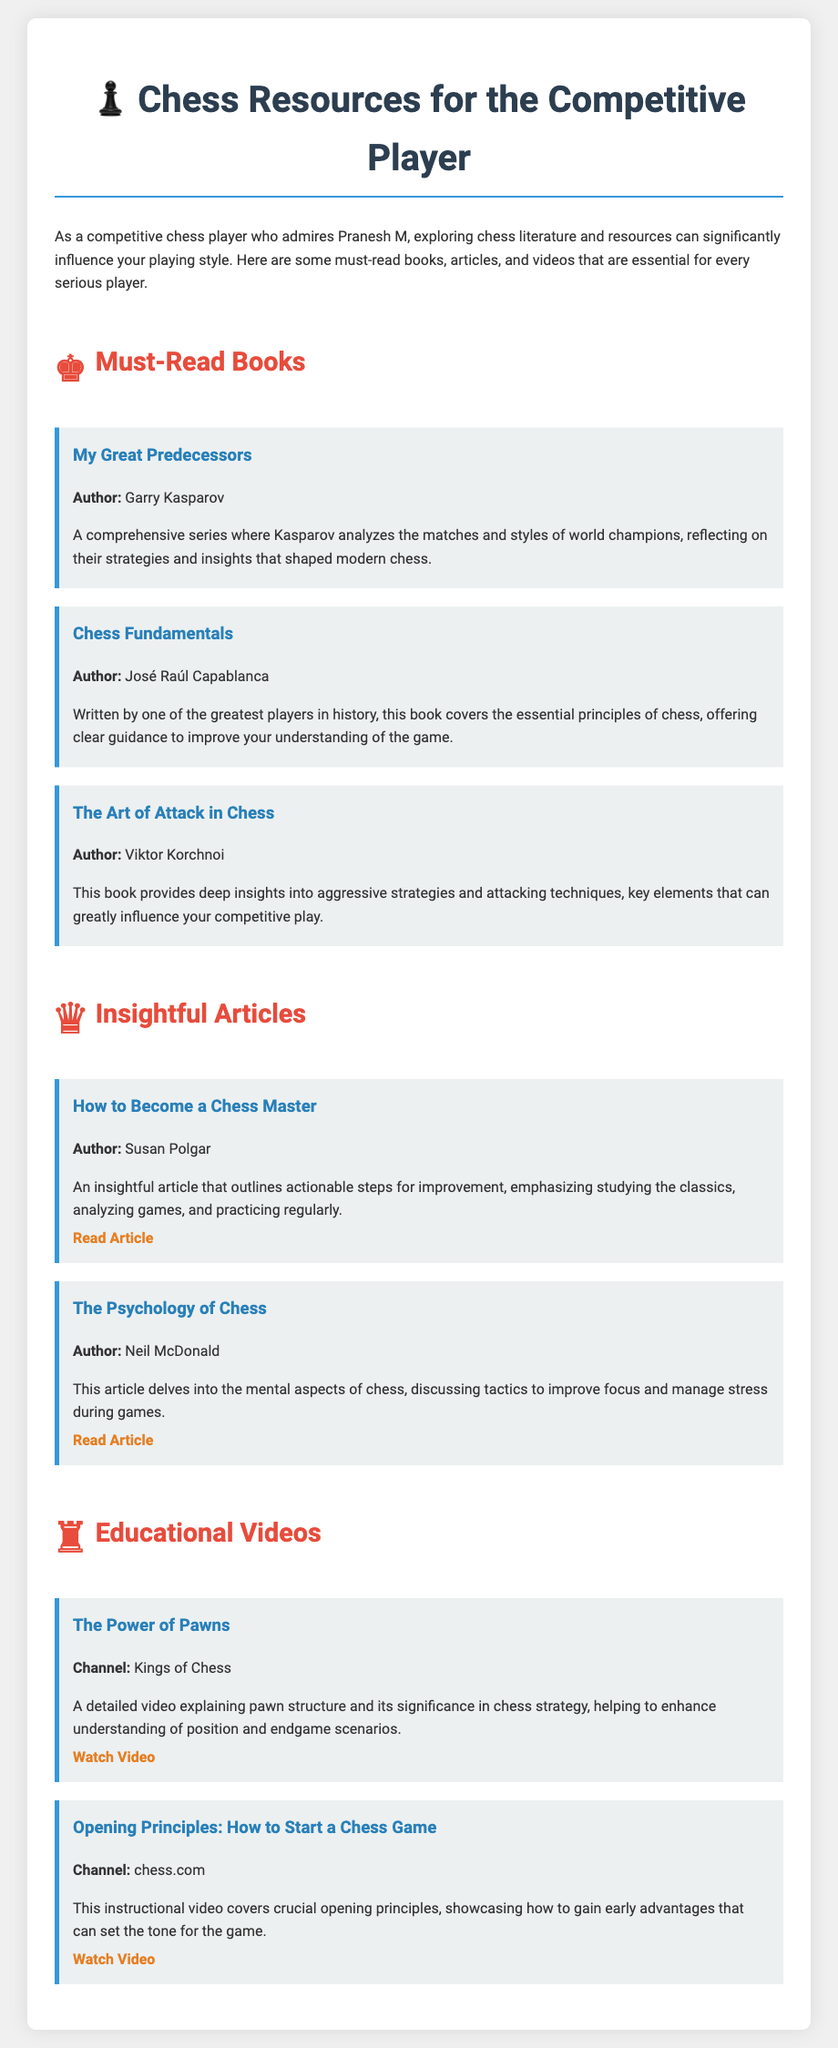What is the title of the book authored by Garry Kasparov? The title of the book authored by Garry Kasparov is provided in the must-read books section.
Answer: My Great Predecessors Who wrote "Chess Fundamentals"? The author of "Chess Fundamentals" is listed in the document under must-read books.
Answer: José Raúl Capablanca What type of resource is "The Power of Pawns"? "The Power of Pawns" is categorized as an educational video in the document.
Answer: Educational video Which article emphasizes studying the classics? The article that emphasizes studying the classics is mentioned in the insightful articles section.
Answer: How to Become a Chess Master What is the main focus of Viktor Korchnoi's book? The focus of Viktor Korchnoi's book is explained in the must-read books section and deals with strategies.
Answer: Aggressive strategies and attacking techniques How many insightful articles are listed in the document? The document specifies a total count of insightful articles under the articles section.
Answer: Two Which channel published the video about opening principles? The channel that published the video about opening principles is mentioned in the educational videos section.
Answer: chess.com What is the main theme of Neil McDonald's article? The main theme of Neil McDonald's article is outlined in the insightful articles section and deals with mental aspects.
Answer: The psychology of chess 